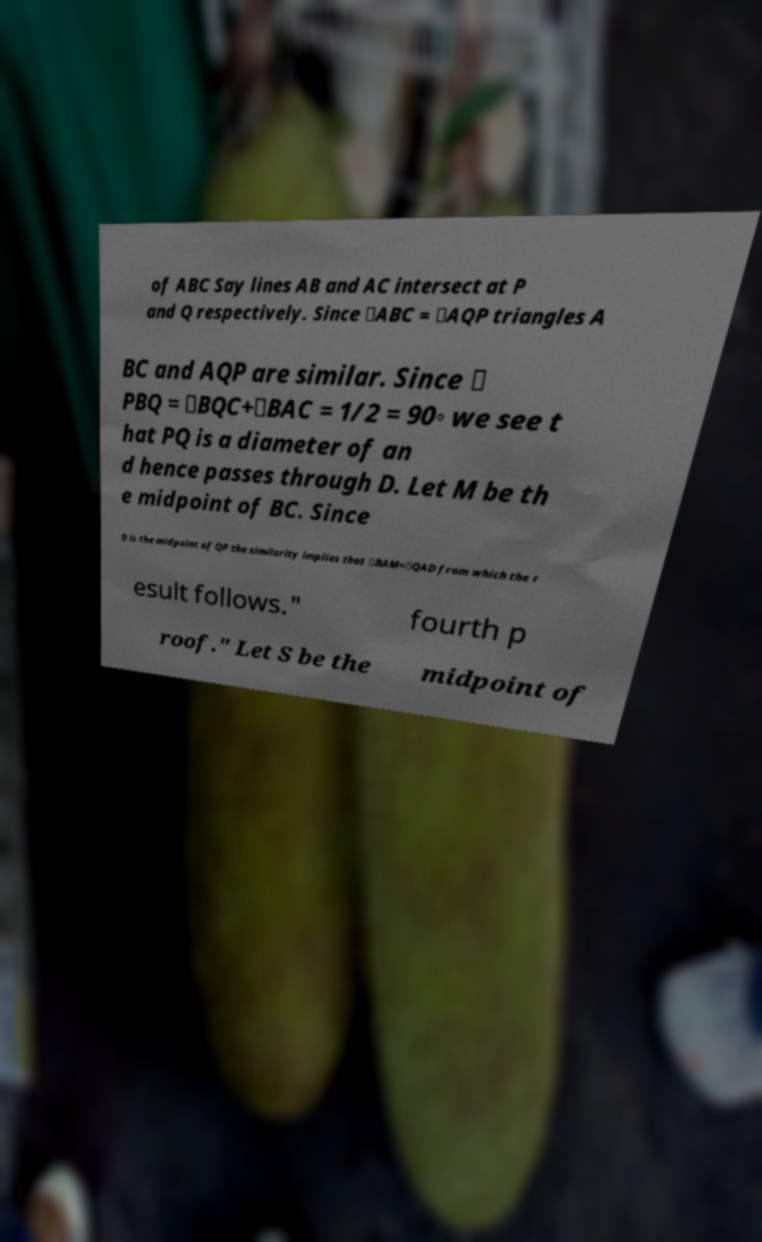Please read and relay the text visible in this image. What does it say? of ABC Say lines AB and AC intersect at P and Q respectively. Since ∠ABC = ∠AQP triangles A BC and AQP are similar. Since ∠ PBQ = ∠BQC+∠BAC = 1/2 = 90◦ we see t hat PQ is a diameter of an d hence passes through D. Let M be th e midpoint of BC. Since D is the midpoint of QP the similarity implies that ∠BAM=∠QAD from which the r esult follows." fourth p roof." Let S be the midpoint of 